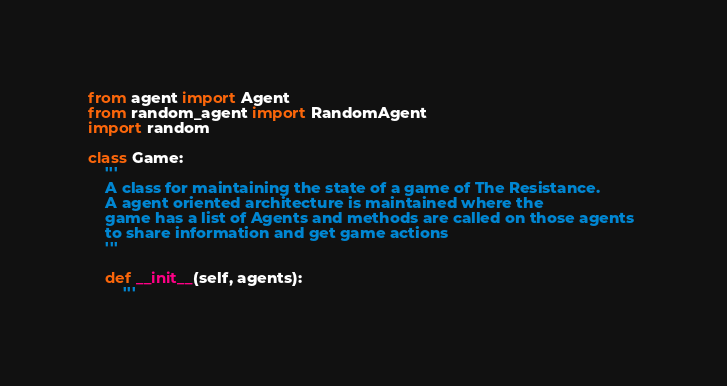<code> <loc_0><loc_0><loc_500><loc_500><_Python_>from agent import Agent
from random_agent import RandomAgent
import random

class Game:
    '''
    A class for maintaining the state of a game of The Resistance.
    A agent oriented architecture is maintained where the 
    game has a list of Agents and methods are called on those agents 
    to share information and get game actions
    '''

    def __init__(self, agents):
        '''</code> 